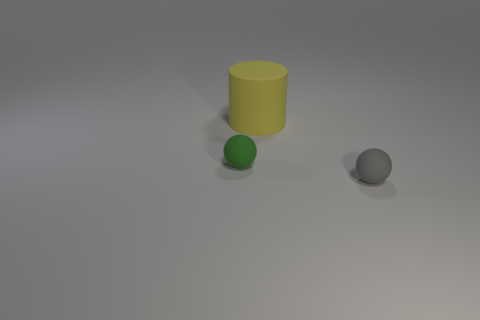There is a rubber ball that is right of the large object; are there any small green matte balls that are in front of it?
Offer a terse response. No. Does the thing that is behind the tiny green object have the same color as the sphere on the right side of the green rubber sphere?
Offer a terse response. No. There is another matte object that is the same size as the green object; what color is it?
Make the answer very short. Gray. Are there an equal number of green balls that are in front of the gray rubber ball and tiny green matte things that are on the right side of the large cylinder?
Make the answer very short. Yes. The small object that is to the right of the sphere on the left side of the large matte cylinder is made of what material?
Your answer should be very brief. Rubber. What number of objects are either matte cylinders or red shiny objects?
Offer a terse response. 1. Are there fewer small green balls than small brown metal cylinders?
Your response must be concise. No. There is another ball that is the same material as the green sphere; what size is it?
Your answer should be compact. Small. What size is the gray rubber ball?
Keep it short and to the point. Small. The large object is what shape?
Provide a short and direct response. Cylinder. 